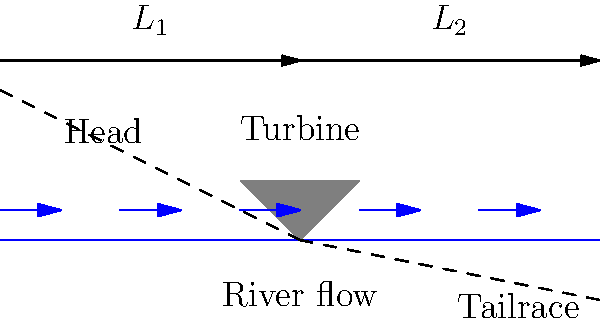A small-scale hydroelectric system is being designed for a remote village in Bosnia. The system utilizes a river with a total length of 200 meters, divided into two sections: $L_1$ and $L_2$. The head (height difference) is 50 meters, and the tailrace has a 10-degree downward slope. If the turbine is placed at the midpoint of the river, calculate the length of $L_1$ in meters. To solve this problem, we'll follow these steps:

1) First, we know that the turbine is placed at the midpoint of the river. This means:
   $L_1 + L_2 = 200$ meters
   $L_1 = L_2 = 100$ meters (initially)

2) We need to verify if this initial assumption satisfies the given conditions. Let's focus on the tailrace (L_2):

3) The tailrace has a 10-degree downward slope. We can use trigonometry to relate this to the horizontal distance (L_2) and the vertical drop.

4) The total vertical drop is 50 meters (the head). Let's call the vertical drop in the tailrace $h$:

   $\tan(10°) = \frac{h}{L_2}$

5) Rearranging this equation:
   $h = L_2 \cdot \tan(10°)$

6) We can calculate this:
   $h = 100 \cdot \tan(10°) = 17.63$ meters

7) This means the vertical drop in the head section must be:
   $50 - 17.63 = 32.37$ meters

8) Now, we can use the Pythagorean theorem to calculate the actual length of L_1:

   $L_1^2 = 100^2 + 32.37^2$

9) Solving for L_1:
   $L_1 = \sqrt{100^2 + 32.37^2} = 105.23$ meters

Therefore, the length of L_1 is approximately 105.23 meters.
Answer: 105.23 meters 